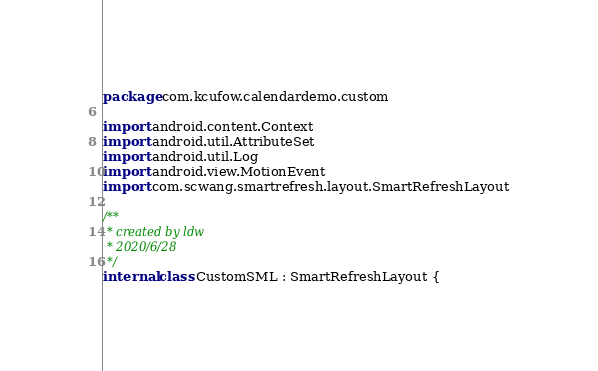Convert code to text. <code><loc_0><loc_0><loc_500><loc_500><_Kotlin_>package com.kcufow.calendardemo.custom

import android.content.Context
import android.util.AttributeSet
import android.util.Log
import android.view.MotionEvent
import com.scwang.smartrefresh.layout.SmartRefreshLayout

/**
 * created by ldw
 * 2020/6/28
 */
internal class CustomSML : SmartRefreshLayout {</code> 